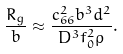Convert formula to latex. <formula><loc_0><loc_0><loc_500><loc_500>\frac { R _ { g } } { b } \approx \frac { c _ { 6 6 } ^ { 2 } b ^ { 3 } d ^ { 2 } } { D ^ { 3 } f _ { 0 } ^ { 2 } \rho } .</formula> 